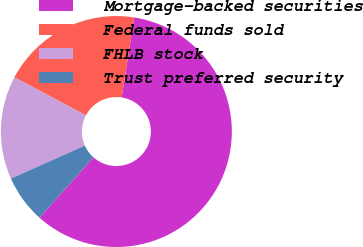<chart> <loc_0><loc_0><loc_500><loc_500><pie_chart><fcel>Mortgage-backed securities<fcel>Federal funds sold<fcel>FHLB stock<fcel>Trust preferred security<nl><fcel>59.12%<fcel>19.7%<fcel>14.46%<fcel>6.72%<nl></chart> 